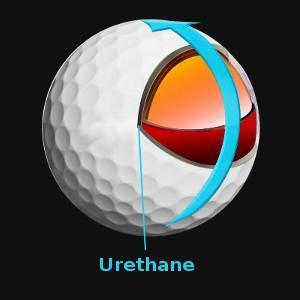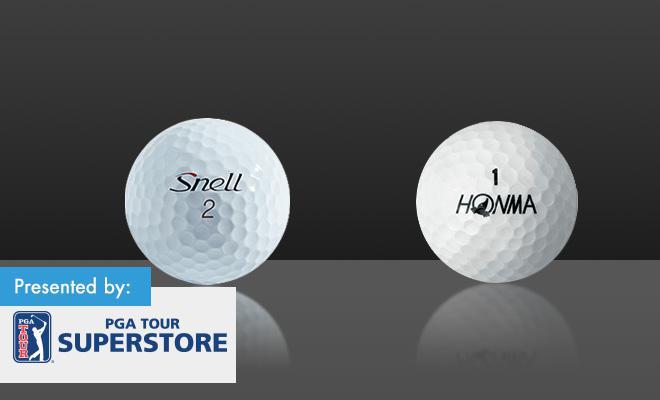The first image is the image on the left, the second image is the image on the right. Analyze the images presented: Is the assertion "An image shows at least four interior layers of a white golf ball." valid? Answer yes or no. No. The first image is the image on the left, the second image is the image on the right. Considering the images on both sides, is "Both images show the inside of a golf ball." valid? Answer yes or no. No. 